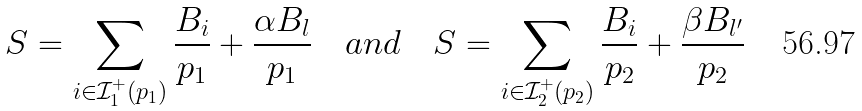<formula> <loc_0><loc_0><loc_500><loc_500>S = \sum _ { i \in \mathcal { I } _ { 1 } ^ { + } ( p _ { 1 } ) } \frac { B _ { i } } { p _ { 1 } } + \frac { \alpha B _ { l } } { p _ { 1 } } \quad a n d \quad S = \sum _ { i \in \mathcal { I } _ { 2 } ^ { + } ( p _ { 2 } ) } \frac { B _ { i } } { p _ { 2 } } + \frac { \beta B _ { l ^ { \prime } } } { p _ { 2 } }</formula> 